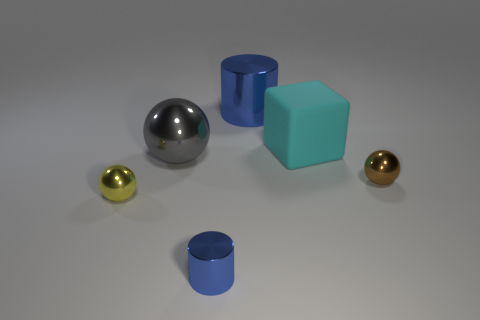Subtract all yellow balls. How many balls are left? 2 Subtract all gray balls. How many balls are left? 2 Subtract 3 spheres. How many spheres are left? 0 Add 4 blue shiny cylinders. How many objects exist? 10 Subtract all cubes. How many objects are left? 5 Subtract all purple cylinders. How many blue balls are left? 0 Subtract all green cylinders. Subtract all gray blocks. How many cylinders are left? 2 Add 2 large cyan objects. How many large cyan objects are left? 3 Add 1 tiny cyan metal objects. How many tiny cyan metal objects exist? 1 Subtract 0 blue balls. How many objects are left? 6 